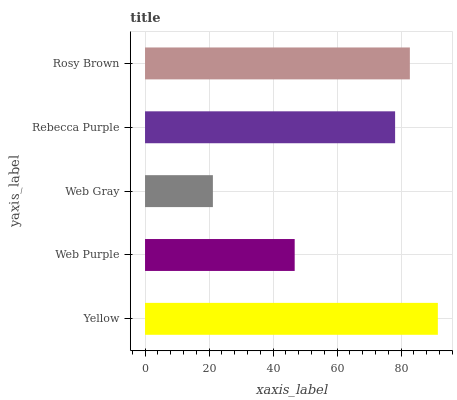Is Web Gray the minimum?
Answer yes or no. Yes. Is Yellow the maximum?
Answer yes or no. Yes. Is Web Purple the minimum?
Answer yes or no. No. Is Web Purple the maximum?
Answer yes or no. No. Is Yellow greater than Web Purple?
Answer yes or no. Yes. Is Web Purple less than Yellow?
Answer yes or no. Yes. Is Web Purple greater than Yellow?
Answer yes or no. No. Is Yellow less than Web Purple?
Answer yes or no. No. Is Rebecca Purple the high median?
Answer yes or no. Yes. Is Rebecca Purple the low median?
Answer yes or no. Yes. Is Web Gray the high median?
Answer yes or no. No. Is Web Purple the low median?
Answer yes or no. No. 